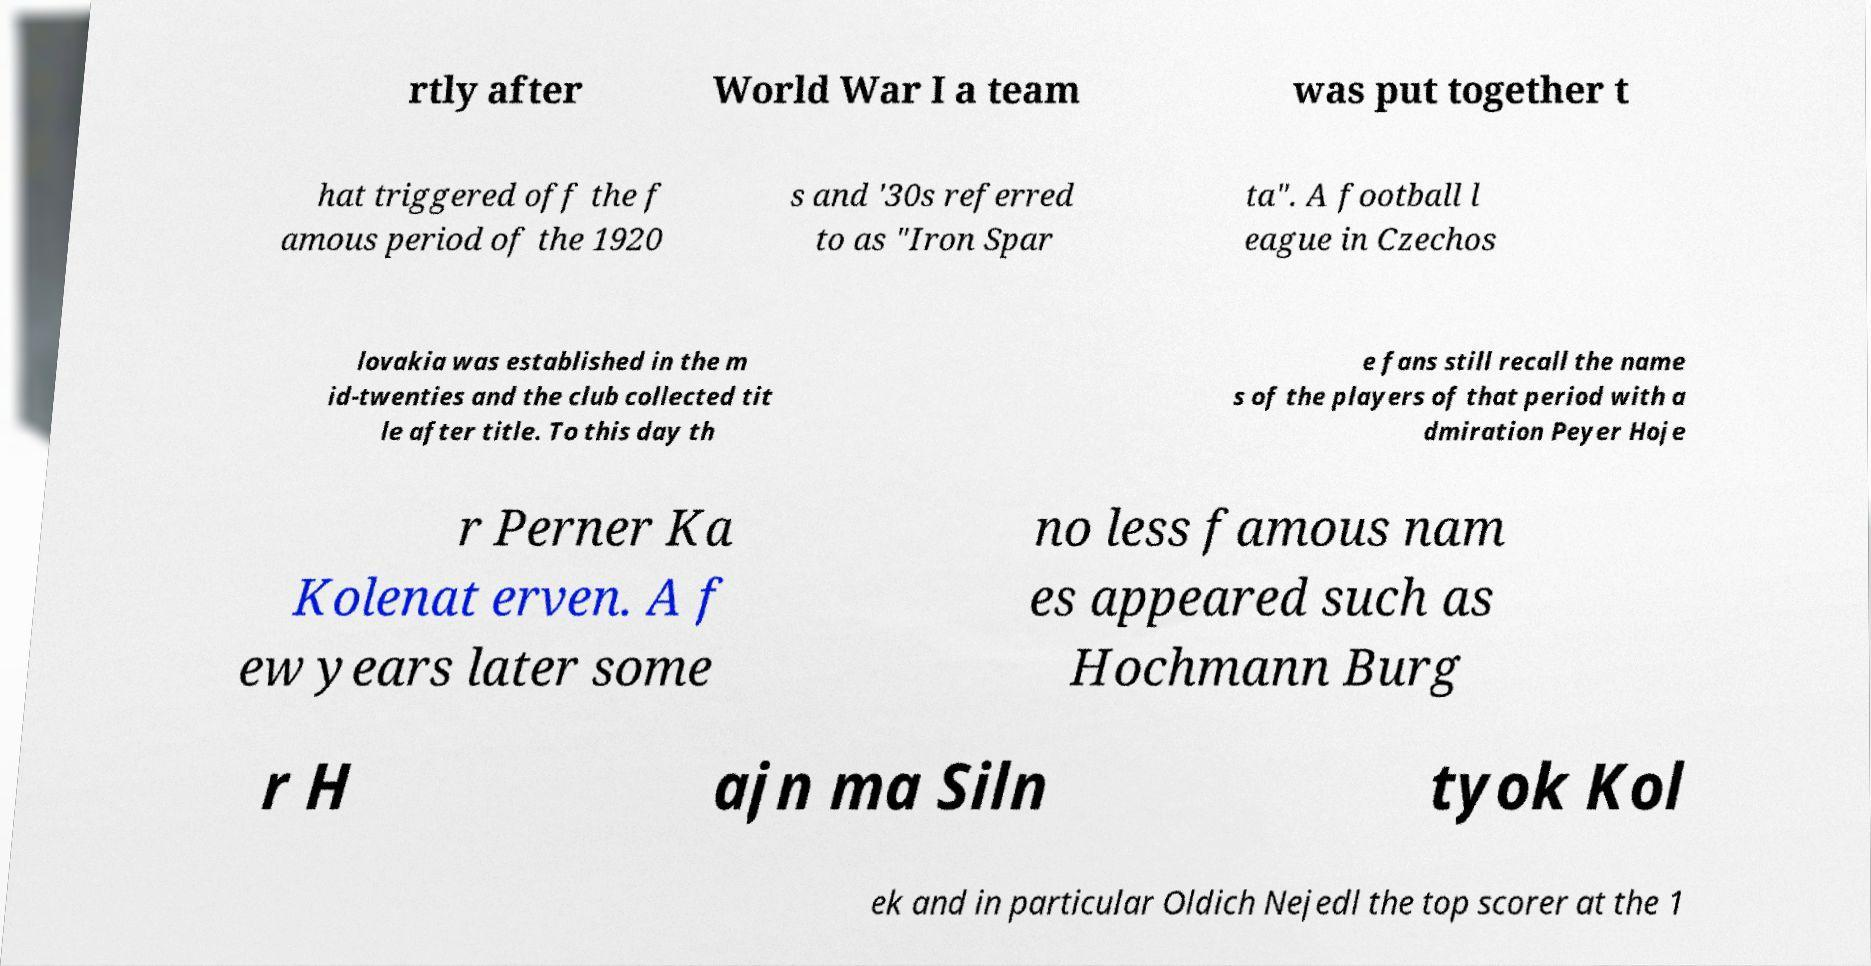Please identify and transcribe the text found in this image. rtly after World War I a team was put together t hat triggered off the f amous period of the 1920 s and '30s referred to as "Iron Spar ta". A football l eague in Czechos lovakia was established in the m id-twenties and the club collected tit le after title. To this day th e fans still recall the name s of the players of that period with a dmiration Peyer Hoje r Perner Ka Kolenat erven. A f ew years later some no less famous nam es appeared such as Hochmann Burg r H ajn ma Siln tyok Kol ek and in particular Oldich Nejedl the top scorer at the 1 